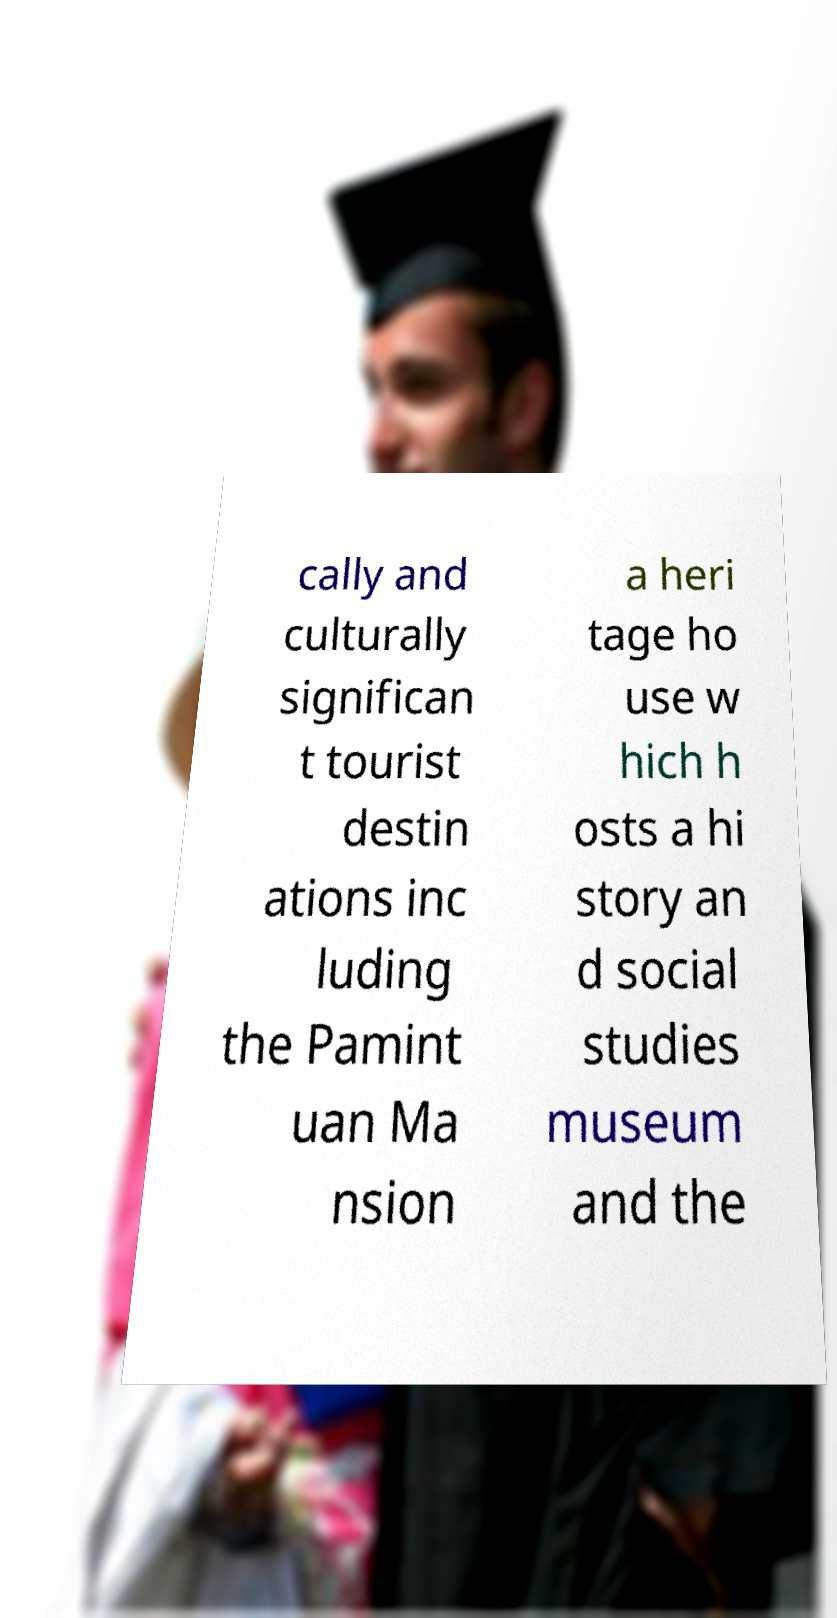Please identify and transcribe the text found in this image. cally and culturally significan t tourist destin ations inc luding the Pamint uan Ma nsion a heri tage ho use w hich h osts a hi story an d social studies museum and the 